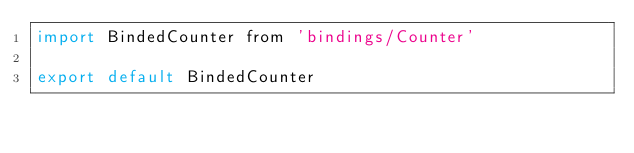Convert code to text. <code><loc_0><loc_0><loc_500><loc_500><_JavaScript_>import BindedCounter from 'bindings/Counter'

export default BindedCounter
</code> 